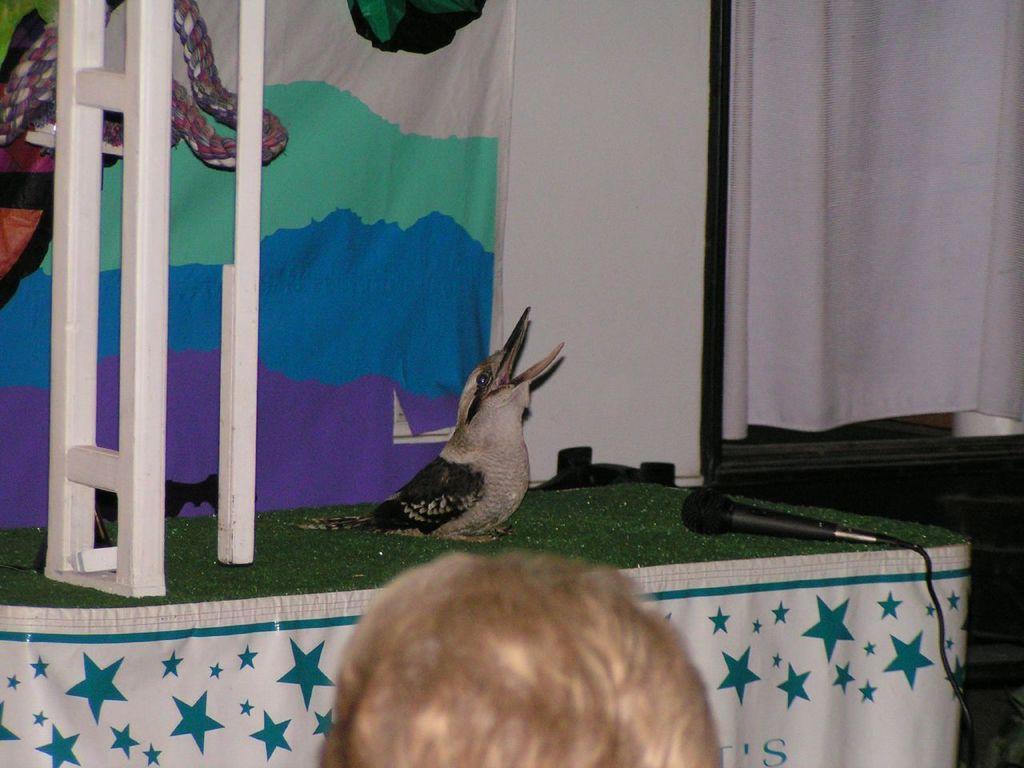How would you summarize this image in a sentence or two? In this image a bird is sitting on the table covered with a cloth having a mike on it. There is a pole having rope on it. Behind there is a curtain to the wall. Bottom of image there is a person. Right side there is a window covered with a curtain. 